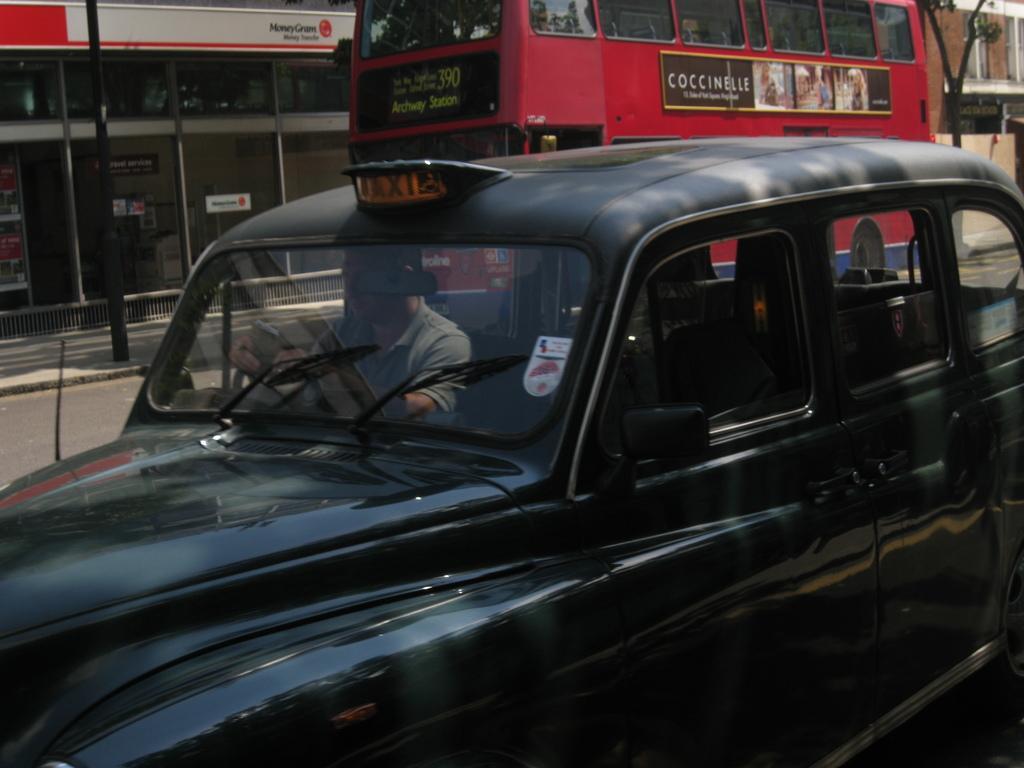Describe this image in one or two sentences. In this picture there is a man riding a black car. In the background there is a bus, building and a tree. 